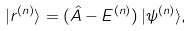<formula> <loc_0><loc_0><loc_500><loc_500>| r ^ { ( n ) } \rangle = ( \hat { A } - E ^ { ( n ) } ) \, | \psi ^ { ( n ) } \rangle ,</formula> 